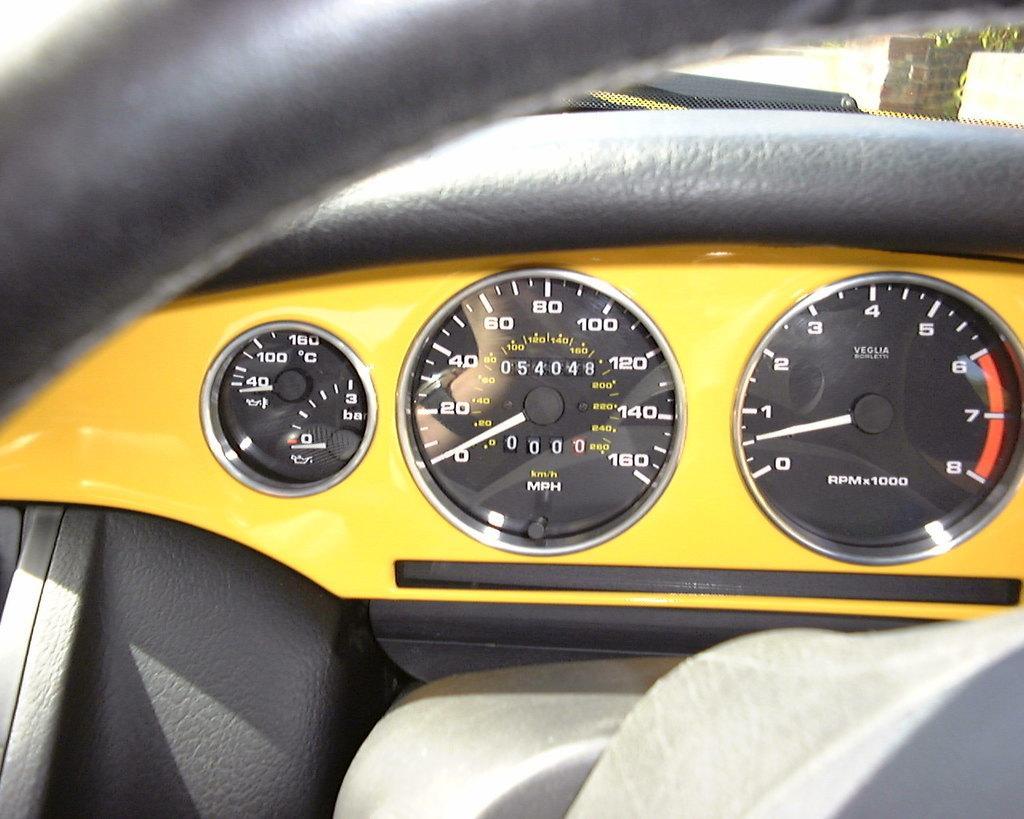Please provide a concise description of this image. This picture shows a vehicle's odometer and we see a steering. It is black and yellow in color. 